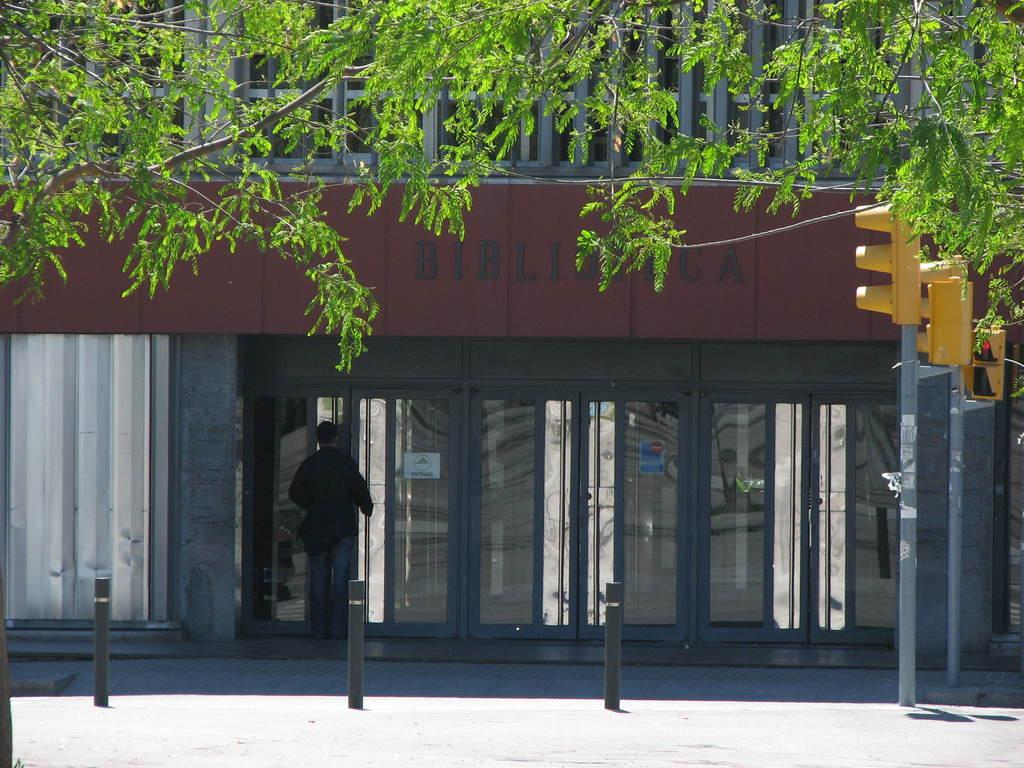What type of structure is visible in the image? There is a building in the image. What other natural elements can be seen in the image? There are trees in the image. What are the vertical structures in the image used for? There are poles in the image, which are likely used for supporting lights or other fixtures. Can you describe the lighting in the image? There are lights in the image, which provide illumination. What type of access points are available in the building? There are doors in the image, which provide access to the building. Are there any people present in the image? Yes, there is a person in the image. What type of business is being conducted in the image? There is no indication of a business being conducted in the image. 